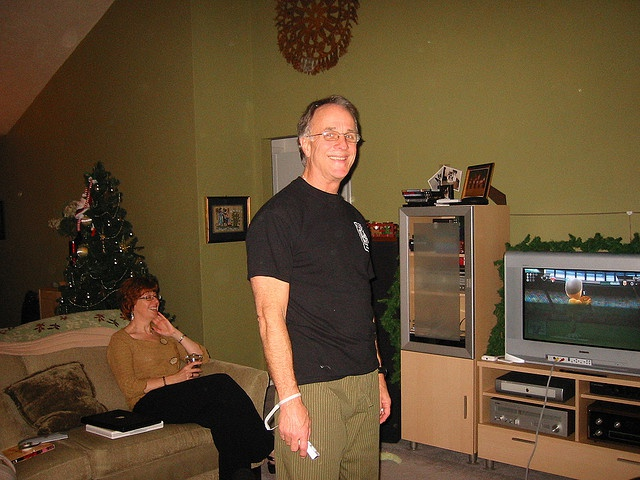Describe the objects in this image and their specific colors. I can see people in maroon, black, gray, and salmon tones, couch in maroon, black, and gray tones, tv in maroon, black, gray, and darkgray tones, people in maroon, black, brown, and salmon tones, and remote in maroon, white, gray, and darkgray tones in this image. 